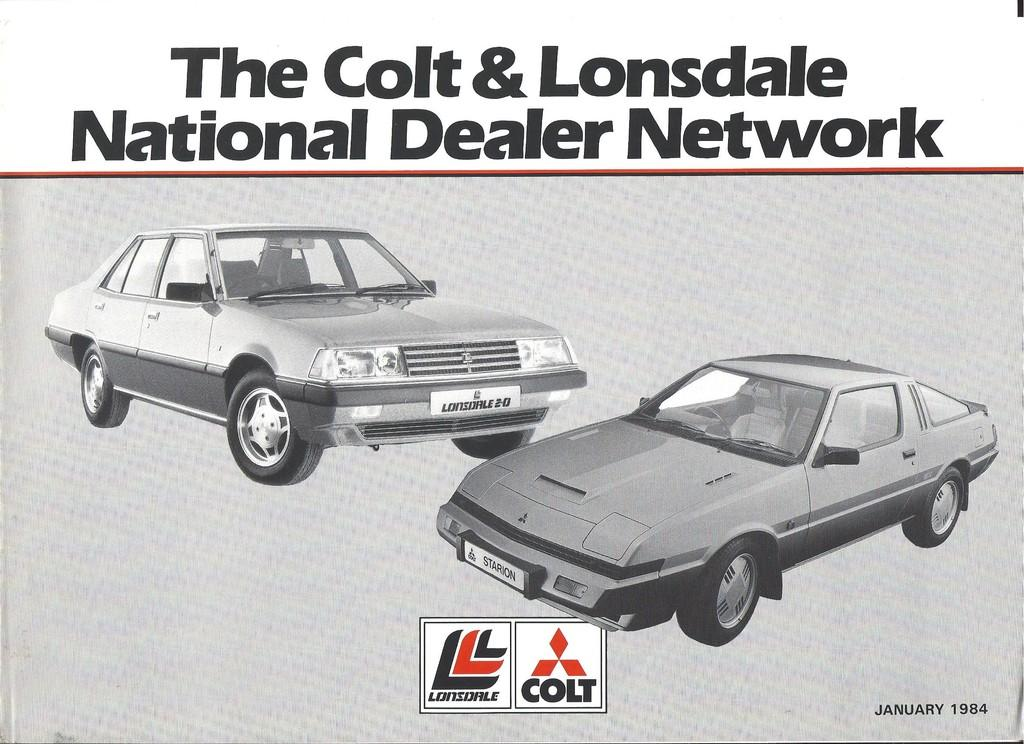What is present on the paper in the image? There is a paper in the image. What is depicted on the paper? There are vehicles depicted on the paper. Is there any text or writing on the paper? Yes, there is writing on the paper. Where are the cherries located in the image? There are no cherries present in the image. What type of powder can be seen covering the vehicles on the paper? There is no powder present in the image, and the vehicles are not depicted as being covered in any substance. 